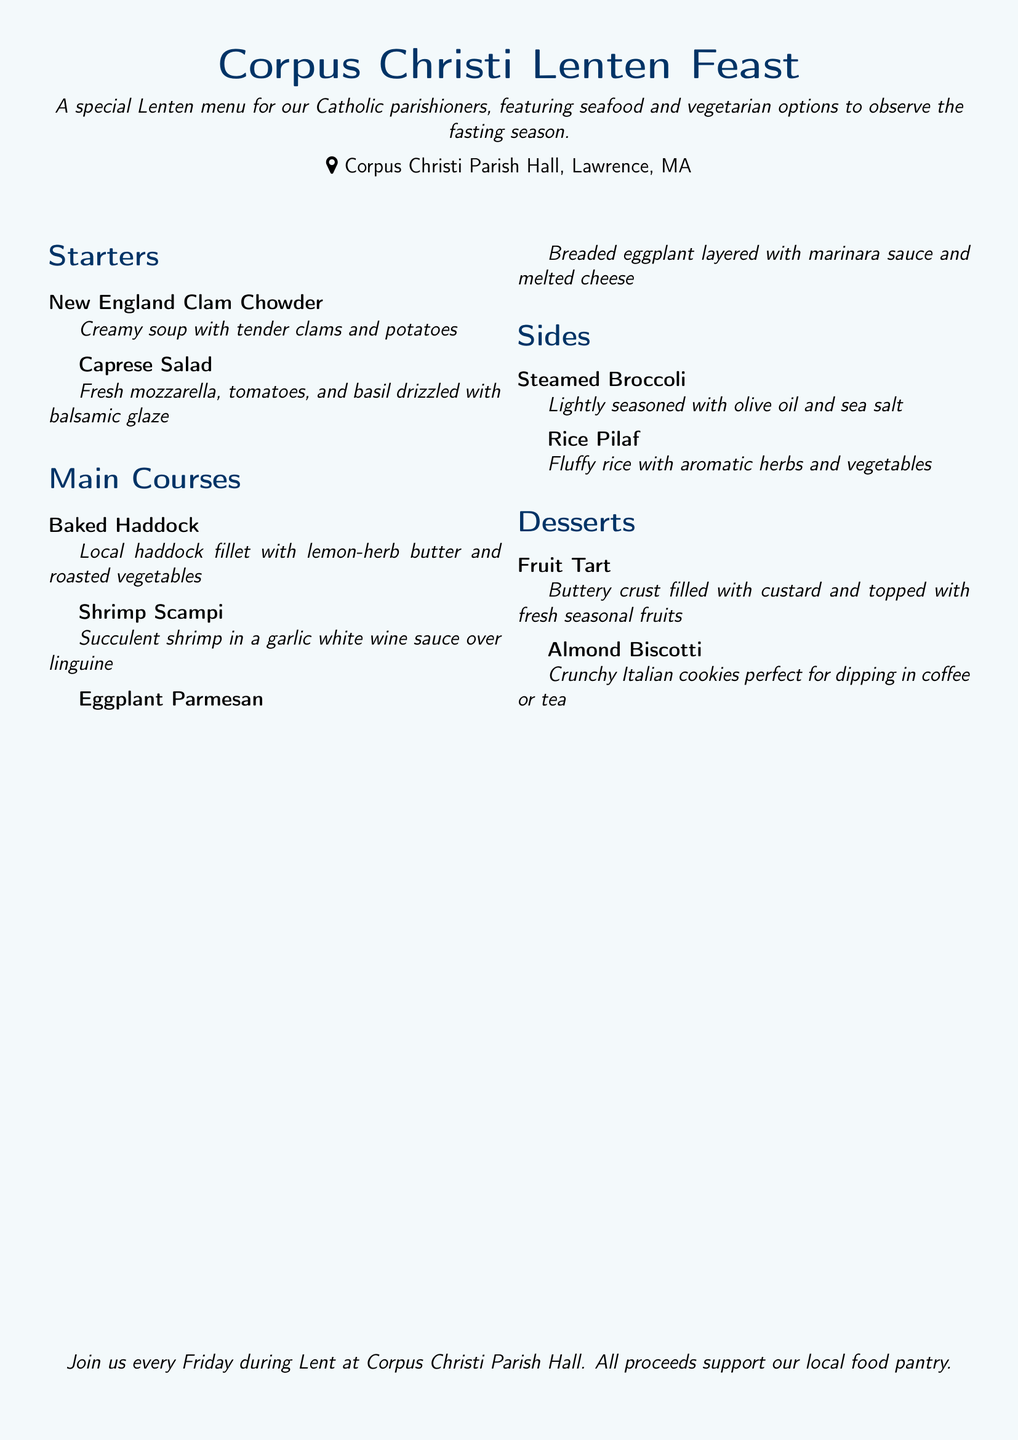What is the name of the parish hosting the menu? The name of the parish is mentioned at the top of the document, which is Corpus Christi Parish.
Answer: Corpus Christi Parish What type of menu is featured? The document clearly states that this is a special Lenten menu designed for Catholic parishioners.
Answer: Lenten menu How many main courses are listed in the menu? The document provides three main courses under the main courses section.
Answer: 3 What dessert includes fresh seasonal fruits? The dessert description specifies that the Fruit Tart is topped with fresh seasonal fruits.
Answer: Fruit Tart What are the ingredients in the Caprese Salad? The Caprese Salad is described as having fresh mozzarella, tomatoes, and basil.
Answer: Fresh mozzarella, tomatoes, basil Which main course features eggplant? The main course that features eggplant is Eggplant Parmesan, as listed in the document.
Answer: Eggplant Parmesan What is the location of Corpus Christi Parish Hall? The document indicates that the parish hall is located in Lawrence, MA.
Answer: Lawrence, MA What type of cookies are mentioned in the dessert section? The document mentions Almond Biscotti as the type of cookies available in the dessert section.
Answer: Almond Biscotti What is the main protein in Baked Haddock? The main protein highlighted in the dish Baked Haddock is local haddock fillet.
Answer: Haddock fillet 